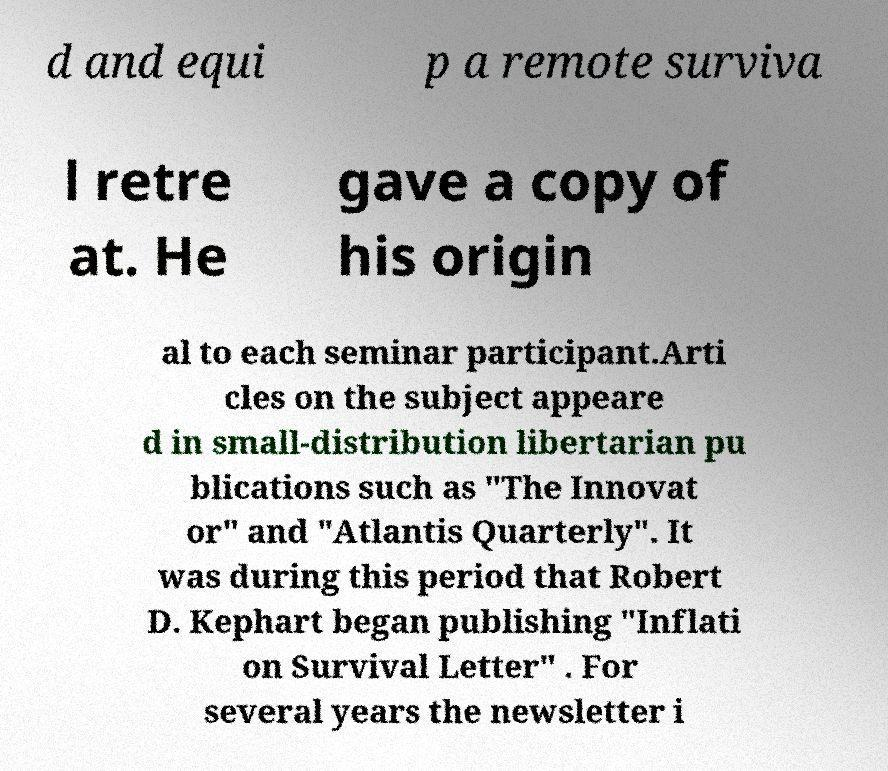Please read and relay the text visible in this image. What does it say? d and equi p a remote surviva l retre at. He gave a copy of his origin al to each seminar participant.Arti cles on the subject appeare d in small-distribution libertarian pu blications such as "The Innovat or" and "Atlantis Quarterly". It was during this period that Robert D. Kephart began publishing "Inflati on Survival Letter" . For several years the newsletter i 